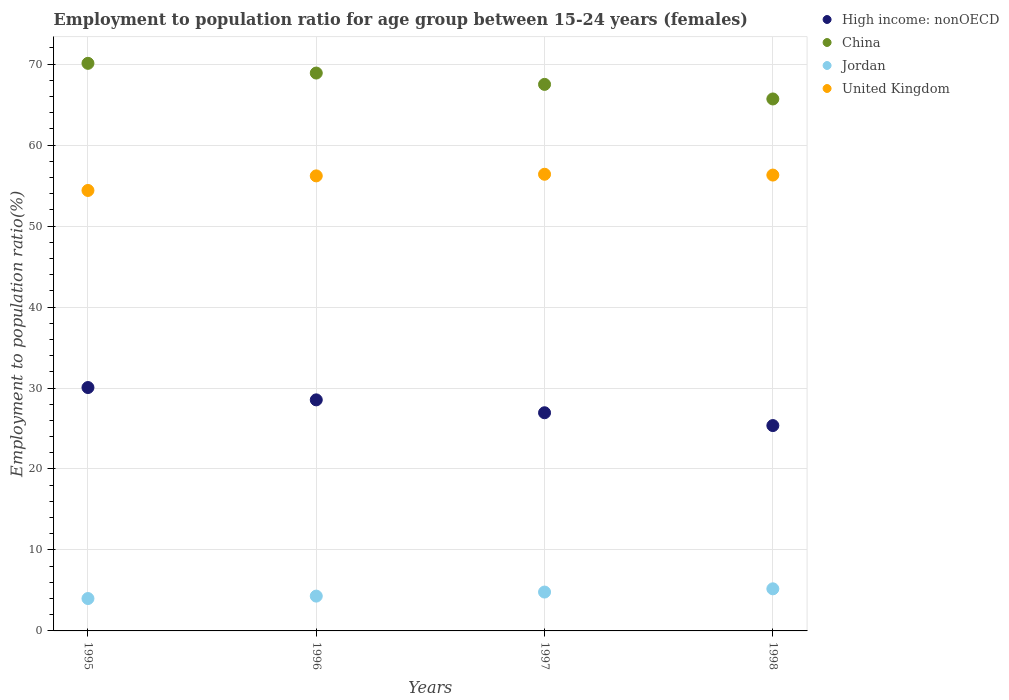Is the number of dotlines equal to the number of legend labels?
Provide a succinct answer. Yes. What is the employment to population ratio in China in 1996?
Offer a terse response. 68.9. Across all years, what is the maximum employment to population ratio in Jordan?
Provide a short and direct response. 5.2. Across all years, what is the minimum employment to population ratio in High income: nonOECD?
Provide a short and direct response. 25.36. In which year was the employment to population ratio in Jordan maximum?
Your response must be concise. 1998. In which year was the employment to population ratio in High income: nonOECD minimum?
Provide a short and direct response. 1998. What is the total employment to population ratio in United Kingdom in the graph?
Give a very brief answer. 223.3. What is the difference between the employment to population ratio in China in 1996 and that in 1998?
Keep it short and to the point. 3.2. What is the difference between the employment to population ratio in High income: nonOECD in 1998 and the employment to population ratio in China in 1997?
Keep it short and to the point. -42.14. What is the average employment to population ratio in High income: nonOECD per year?
Keep it short and to the point. 27.73. In the year 1997, what is the difference between the employment to population ratio in Jordan and employment to population ratio in United Kingdom?
Make the answer very short. -51.6. In how many years, is the employment to population ratio in United Kingdom greater than 22 %?
Make the answer very short. 4. What is the ratio of the employment to population ratio in High income: nonOECD in 1996 to that in 1997?
Your answer should be very brief. 1.06. Is the employment to population ratio in China in 1996 less than that in 1998?
Offer a terse response. No. What is the difference between the highest and the second highest employment to population ratio in High income: nonOECD?
Ensure brevity in your answer.  1.52. What is the difference between the highest and the lowest employment to population ratio in China?
Ensure brevity in your answer.  4.4. In how many years, is the employment to population ratio in United Kingdom greater than the average employment to population ratio in United Kingdom taken over all years?
Provide a short and direct response. 3. Is it the case that in every year, the sum of the employment to population ratio in Jordan and employment to population ratio in High income: nonOECD  is greater than the employment to population ratio in China?
Offer a very short reply. No. Does the employment to population ratio in China monotonically increase over the years?
Give a very brief answer. No. How many dotlines are there?
Ensure brevity in your answer.  4. How many years are there in the graph?
Your response must be concise. 4. Does the graph contain grids?
Your answer should be compact. Yes. How many legend labels are there?
Provide a succinct answer. 4. What is the title of the graph?
Provide a short and direct response. Employment to population ratio for age group between 15-24 years (females). Does "Germany" appear as one of the legend labels in the graph?
Provide a short and direct response. No. What is the label or title of the X-axis?
Offer a terse response. Years. What is the label or title of the Y-axis?
Ensure brevity in your answer.  Employment to population ratio(%). What is the Employment to population ratio(%) of High income: nonOECD in 1995?
Your answer should be compact. 30.06. What is the Employment to population ratio(%) of China in 1995?
Give a very brief answer. 70.1. What is the Employment to population ratio(%) of United Kingdom in 1995?
Your answer should be very brief. 54.4. What is the Employment to population ratio(%) in High income: nonOECD in 1996?
Keep it short and to the point. 28.54. What is the Employment to population ratio(%) of China in 1996?
Keep it short and to the point. 68.9. What is the Employment to population ratio(%) of Jordan in 1996?
Your response must be concise. 4.3. What is the Employment to population ratio(%) of United Kingdom in 1996?
Offer a terse response. 56.2. What is the Employment to population ratio(%) of High income: nonOECD in 1997?
Your answer should be very brief. 26.94. What is the Employment to population ratio(%) of China in 1997?
Offer a terse response. 67.5. What is the Employment to population ratio(%) in Jordan in 1997?
Provide a succinct answer. 4.8. What is the Employment to population ratio(%) in United Kingdom in 1997?
Offer a terse response. 56.4. What is the Employment to population ratio(%) in High income: nonOECD in 1998?
Make the answer very short. 25.36. What is the Employment to population ratio(%) in China in 1998?
Keep it short and to the point. 65.7. What is the Employment to population ratio(%) in Jordan in 1998?
Your answer should be very brief. 5.2. What is the Employment to population ratio(%) of United Kingdom in 1998?
Your answer should be very brief. 56.3. Across all years, what is the maximum Employment to population ratio(%) in High income: nonOECD?
Keep it short and to the point. 30.06. Across all years, what is the maximum Employment to population ratio(%) of China?
Keep it short and to the point. 70.1. Across all years, what is the maximum Employment to population ratio(%) of Jordan?
Ensure brevity in your answer.  5.2. Across all years, what is the maximum Employment to population ratio(%) in United Kingdom?
Keep it short and to the point. 56.4. Across all years, what is the minimum Employment to population ratio(%) of High income: nonOECD?
Offer a very short reply. 25.36. Across all years, what is the minimum Employment to population ratio(%) in China?
Your answer should be very brief. 65.7. Across all years, what is the minimum Employment to population ratio(%) of United Kingdom?
Provide a succinct answer. 54.4. What is the total Employment to population ratio(%) in High income: nonOECD in the graph?
Offer a terse response. 110.9. What is the total Employment to population ratio(%) of China in the graph?
Keep it short and to the point. 272.2. What is the total Employment to population ratio(%) in Jordan in the graph?
Ensure brevity in your answer.  18.3. What is the total Employment to population ratio(%) in United Kingdom in the graph?
Your response must be concise. 223.3. What is the difference between the Employment to population ratio(%) in High income: nonOECD in 1995 and that in 1996?
Provide a succinct answer. 1.52. What is the difference between the Employment to population ratio(%) in High income: nonOECD in 1995 and that in 1997?
Offer a very short reply. 3.12. What is the difference between the Employment to population ratio(%) in Jordan in 1995 and that in 1997?
Give a very brief answer. -0.8. What is the difference between the Employment to population ratio(%) of United Kingdom in 1995 and that in 1997?
Provide a short and direct response. -2. What is the difference between the Employment to population ratio(%) in High income: nonOECD in 1995 and that in 1998?
Offer a terse response. 4.7. What is the difference between the Employment to population ratio(%) of China in 1995 and that in 1998?
Provide a short and direct response. 4.4. What is the difference between the Employment to population ratio(%) in High income: nonOECD in 1996 and that in 1997?
Ensure brevity in your answer.  1.59. What is the difference between the Employment to population ratio(%) in Jordan in 1996 and that in 1997?
Your answer should be compact. -0.5. What is the difference between the Employment to population ratio(%) in United Kingdom in 1996 and that in 1997?
Your answer should be very brief. -0.2. What is the difference between the Employment to population ratio(%) in High income: nonOECD in 1996 and that in 1998?
Your response must be concise. 3.17. What is the difference between the Employment to population ratio(%) of Jordan in 1996 and that in 1998?
Provide a short and direct response. -0.9. What is the difference between the Employment to population ratio(%) in High income: nonOECD in 1997 and that in 1998?
Provide a succinct answer. 1.58. What is the difference between the Employment to population ratio(%) in China in 1997 and that in 1998?
Ensure brevity in your answer.  1.8. What is the difference between the Employment to population ratio(%) in United Kingdom in 1997 and that in 1998?
Ensure brevity in your answer.  0.1. What is the difference between the Employment to population ratio(%) of High income: nonOECD in 1995 and the Employment to population ratio(%) of China in 1996?
Offer a terse response. -38.84. What is the difference between the Employment to population ratio(%) of High income: nonOECD in 1995 and the Employment to population ratio(%) of Jordan in 1996?
Your answer should be compact. 25.76. What is the difference between the Employment to population ratio(%) of High income: nonOECD in 1995 and the Employment to population ratio(%) of United Kingdom in 1996?
Ensure brevity in your answer.  -26.14. What is the difference between the Employment to population ratio(%) of China in 1995 and the Employment to population ratio(%) of Jordan in 1996?
Offer a very short reply. 65.8. What is the difference between the Employment to population ratio(%) in Jordan in 1995 and the Employment to population ratio(%) in United Kingdom in 1996?
Your response must be concise. -52.2. What is the difference between the Employment to population ratio(%) of High income: nonOECD in 1995 and the Employment to population ratio(%) of China in 1997?
Your answer should be very brief. -37.44. What is the difference between the Employment to population ratio(%) in High income: nonOECD in 1995 and the Employment to population ratio(%) in Jordan in 1997?
Offer a very short reply. 25.26. What is the difference between the Employment to population ratio(%) in High income: nonOECD in 1995 and the Employment to population ratio(%) in United Kingdom in 1997?
Your response must be concise. -26.34. What is the difference between the Employment to population ratio(%) of China in 1995 and the Employment to population ratio(%) of Jordan in 1997?
Ensure brevity in your answer.  65.3. What is the difference between the Employment to population ratio(%) in China in 1995 and the Employment to population ratio(%) in United Kingdom in 1997?
Keep it short and to the point. 13.7. What is the difference between the Employment to population ratio(%) in Jordan in 1995 and the Employment to population ratio(%) in United Kingdom in 1997?
Make the answer very short. -52.4. What is the difference between the Employment to population ratio(%) in High income: nonOECD in 1995 and the Employment to population ratio(%) in China in 1998?
Provide a short and direct response. -35.64. What is the difference between the Employment to population ratio(%) of High income: nonOECD in 1995 and the Employment to population ratio(%) of Jordan in 1998?
Make the answer very short. 24.86. What is the difference between the Employment to population ratio(%) in High income: nonOECD in 1995 and the Employment to population ratio(%) in United Kingdom in 1998?
Offer a terse response. -26.24. What is the difference between the Employment to population ratio(%) of China in 1995 and the Employment to population ratio(%) of Jordan in 1998?
Make the answer very short. 64.9. What is the difference between the Employment to population ratio(%) in Jordan in 1995 and the Employment to population ratio(%) in United Kingdom in 1998?
Make the answer very short. -52.3. What is the difference between the Employment to population ratio(%) in High income: nonOECD in 1996 and the Employment to population ratio(%) in China in 1997?
Make the answer very short. -38.96. What is the difference between the Employment to population ratio(%) of High income: nonOECD in 1996 and the Employment to population ratio(%) of Jordan in 1997?
Your answer should be very brief. 23.74. What is the difference between the Employment to population ratio(%) of High income: nonOECD in 1996 and the Employment to population ratio(%) of United Kingdom in 1997?
Your response must be concise. -27.86. What is the difference between the Employment to population ratio(%) of China in 1996 and the Employment to population ratio(%) of Jordan in 1997?
Provide a succinct answer. 64.1. What is the difference between the Employment to population ratio(%) in China in 1996 and the Employment to population ratio(%) in United Kingdom in 1997?
Make the answer very short. 12.5. What is the difference between the Employment to population ratio(%) in Jordan in 1996 and the Employment to population ratio(%) in United Kingdom in 1997?
Offer a terse response. -52.1. What is the difference between the Employment to population ratio(%) in High income: nonOECD in 1996 and the Employment to population ratio(%) in China in 1998?
Keep it short and to the point. -37.16. What is the difference between the Employment to population ratio(%) in High income: nonOECD in 1996 and the Employment to population ratio(%) in Jordan in 1998?
Your answer should be compact. 23.34. What is the difference between the Employment to population ratio(%) in High income: nonOECD in 1996 and the Employment to population ratio(%) in United Kingdom in 1998?
Ensure brevity in your answer.  -27.76. What is the difference between the Employment to population ratio(%) of China in 1996 and the Employment to population ratio(%) of Jordan in 1998?
Offer a very short reply. 63.7. What is the difference between the Employment to population ratio(%) in China in 1996 and the Employment to population ratio(%) in United Kingdom in 1998?
Offer a very short reply. 12.6. What is the difference between the Employment to population ratio(%) of Jordan in 1996 and the Employment to population ratio(%) of United Kingdom in 1998?
Your answer should be very brief. -52. What is the difference between the Employment to population ratio(%) of High income: nonOECD in 1997 and the Employment to population ratio(%) of China in 1998?
Your response must be concise. -38.76. What is the difference between the Employment to population ratio(%) of High income: nonOECD in 1997 and the Employment to population ratio(%) of Jordan in 1998?
Offer a very short reply. 21.74. What is the difference between the Employment to population ratio(%) of High income: nonOECD in 1997 and the Employment to population ratio(%) of United Kingdom in 1998?
Your answer should be very brief. -29.36. What is the difference between the Employment to population ratio(%) of China in 1997 and the Employment to population ratio(%) of Jordan in 1998?
Your answer should be compact. 62.3. What is the difference between the Employment to population ratio(%) in China in 1997 and the Employment to population ratio(%) in United Kingdom in 1998?
Your answer should be compact. 11.2. What is the difference between the Employment to population ratio(%) in Jordan in 1997 and the Employment to population ratio(%) in United Kingdom in 1998?
Provide a short and direct response. -51.5. What is the average Employment to population ratio(%) in High income: nonOECD per year?
Your answer should be very brief. 27.73. What is the average Employment to population ratio(%) in China per year?
Offer a terse response. 68.05. What is the average Employment to population ratio(%) in Jordan per year?
Give a very brief answer. 4.58. What is the average Employment to population ratio(%) of United Kingdom per year?
Your response must be concise. 55.83. In the year 1995, what is the difference between the Employment to population ratio(%) in High income: nonOECD and Employment to population ratio(%) in China?
Give a very brief answer. -40.04. In the year 1995, what is the difference between the Employment to population ratio(%) of High income: nonOECD and Employment to population ratio(%) of Jordan?
Make the answer very short. 26.06. In the year 1995, what is the difference between the Employment to population ratio(%) of High income: nonOECD and Employment to population ratio(%) of United Kingdom?
Offer a very short reply. -24.34. In the year 1995, what is the difference between the Employment to population ratio(%) in China and Employment to population ratio(%) in Jordan?
Your answer should be compact. 66.1. In the year 1995, what is the difference between the Employment to population ratio(%) of China and Employment to population ratio(%) of United Kingdom?
Offer a very short reply. 15.7. In the year 1995, what is the difference between the Employment to population ratio(%) of Jordan and Employment to population ratio(%) of United Kingdom?
Your answer should be very brief. -50.4. In the year 1996, what is the difference between the Employment to population ratio(%) in High income: nonOECD and Employment to population ratio(%) in China?
Offer a very short reply. -40.36. In the year 1996, what is the difference between the Employment to population ratio(%) of High income: nonOECD and Employment to population ratio(%) of Jordan?
Offer a terse response. 24.24. In the year 1996, what is the difference between the Employment to population ratio(%) in High income: nonOECD and Employment to population ratio(%) in United Kingdom?
Ensure brevity in your answer.  -27.66. In the year 1996, what is the difference between the Employment to population ratio(%) in China and Employment to population ratio(%) in Jordan?
Your answer should be compact. 64.6. In the year 1996, what is the difference between the Employment to population ratio(%) in Jordan and Employment to population ratio(%) in United Kingdom?
Provide a succinct answer. -51.9. In the year 1997, what is the difference between the Employment to population ratio(%) in High income: nonOECD and Employment to population ratio(%) in China?
Your response must be concise. -40.56. In the year 1997, what is the difference between the Employment to population ratio(%) of High income: nonOECD and Employment to population ratio(%) of Jordan?
Keep it short and to the point. 22.14. In the year 1997, what is the difference between the Employment to population ratio(%) in High income: nonOECD and Employment to population ratio(%) in United Kingdom?
Offer a very short reply. -29.46. In the year 1997, what is the difference between the Employment to population ratio(%) in China and Employment to population ratio(%) in Jordan?
Ensure brevity in your answer.  62.7. In the year 1997, what is the difference between the Employment to population ratio(%) in Jordan and Employment to population ratio(%) in United Kingdom?
Make the answer very short. -51.6. In the year 1998, what is the difference between the Employment to population ratio(%) in High income: nonOECD and Employment to population ratio(%) in China?
Make the answer very short. -40.34. In the year 1998, what is the difference between the Employment to population ratio(%) in High income: nonOECD and Employment to population ratio(%) in Jordan?
Make the answer very short. 20.16. In the year 1998, what is the difference between the Employment to population ratio(%) of High income: nonOECD and Employment to population ratio(%) of United Kingdom?
Make the answer very short. -30.94. In the year 1998, what is the difference between the Employment to population ratio(%) in China and Employment to population ratio(%) in Jordan?
Provide a short and direct response. 60.5. In the year 1998, what is the difference between the Employment to population ratio(%) of Jordan and Employment to population ratio(%) of United Kingdom?
Keep it short and to the point. -51.1. What is the ratio of the Employment to population ratio(%) in High income: nonOECD in 1995 to that in 1996?
Provide a succinct answer. 1.05. What is the ratio of the Employment to population ratio(%) in China in 1995 to that in 1996?
Make the answer very short. 1.02. What is the ratio of the Employment to population ratio(%) in Jordan in 1995 to that in 1996?
Offer a terse response. 0.93. What is the ratio of the Employment to population ratio(%) of High income: nonOECD in 1995 to that in 1997?
Ensure brevity in your answer.  1.12. What is the ratio of the Employment to population ratio(%) of Jordan in 1995 to that in 1997?
Make the answer very short. 0.83. What is the ratio of the Employment to population ratio(%) of United Kingdom in 1995 to that in 1997?
Your answer should be compact. 0.96. What is the ratio of the Employment to population ratio(%) of High income: nonOECD in 1995 to that in 1998?
Ensure brevity in your answer.  1.19. What is the ratio of the Employment to population ratio(%) of China in 1995 to that in 1998?
Ensure brevity in your answer.  1.07. What is the ratio of the Employment to population ratio(%) of Jordan in 1995 to that in 1998?
Give a very brief answer. 0.77. What is the ratio of the Employment to population ratio(%) of United Kingdom in 1995 to that in 1998?
Your answer should be very brief. 0.97. What is the ratio of the Employment to population ratio(%) of High income: nonOECD in 1996 to that in 1997?
Offer a very short reply. 1.06. What is the ratio of the Employment to population ratio(%) in China in 1996 to that in 1997?
Give a very brief answer. 1.02. What is the ratio of the Employment to population ratio(%) of Jordan in 1996 to that in 1997?
Give a very brief answer. 0.9. What is the ratio of the Employment to population ratio(%) in High income: nonOECD in 1996 to that in 1998?
Provide a short and direct response. 1.13. What is the ratio of the Employment to population ratio(%) in China in 1996 to that in 1998?
Your answer should be compact. 1.05. What is the ratio of the Employment to population ratio(%) in Jordan in 1996 to that in 1998?
Make the answer very short. 0.83. What is the ratio of the Employment to population ratio(%) in High income: nonOECD in 1997 to that in 1998?
Offer a very short reply. 1.06. What is the ratio of the Employment to population ratio(%) of China in 1997 to that in 1998?
Provide a succinct answer. 1.03. What is the ratio of the Employment to population ratio(%) in Jordan in 1997 to that in 1998?
Provide a short and direct response. 0.92. What is the difference between the highest and the second highest Employment to population ratio(%) of High income: nonOECD?
Your response must be concise. 1.52. What is the difference between the highest and the second highest Employment to population ratio(%) in Jordan?
Ensure brevity in your answer.  0.4. What is the difference between the highest and the second highest Employment to population ratio(%) in United Kingdom?
Your answer should be very brief. 0.1. What is the difference between the highest and the lowest Employment to population ratio(%) of High income: nonOECD?
Your answer should be very brief. 4.7. What is the difference between the highest and the lowest Employment to population ratio(%) in China?
Your answer should be compact. 4.4. What is the difference between the highest and the lowest Employment to population ratio(%) in Jordan?
Your answer should be very brief. 1.2. What is the difference between the highest and the lowest Employment to population ratio(%) in United Kingdom?
Keep it short and to the point. 2. 